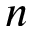<formula> <loc_0><loc_0><loc_500><loc_500>n</formula> 